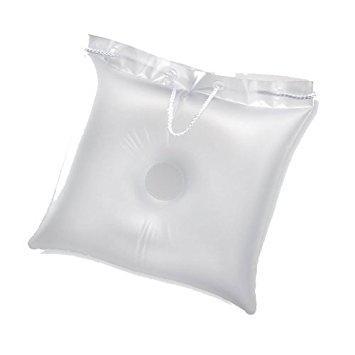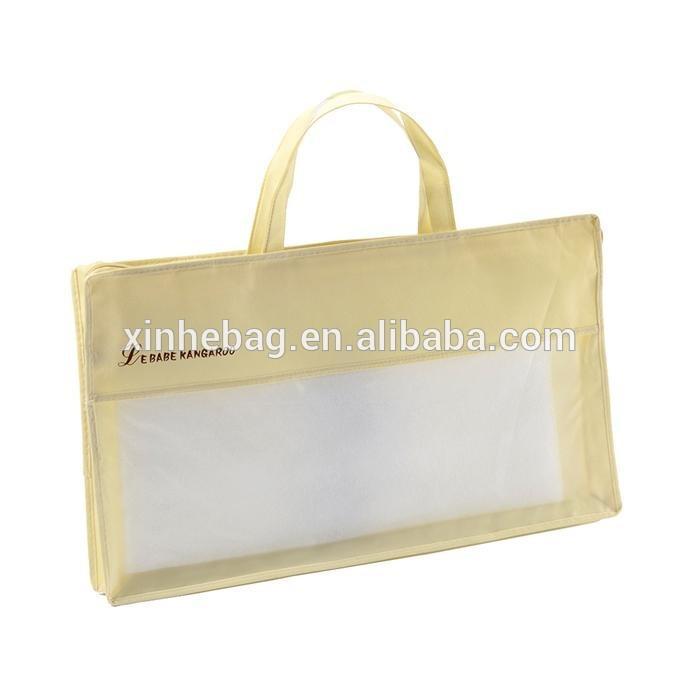The first image is the image on the left, the second image is the image on the right. Examine the images to the left and right. Is the description "The left image contains a handled pillow shape with black text printed on its front, and the right image features a pillow with no handle." accurate? Answer yes or no. No. The first image is the image on the left, the second image is the image on the right. Examine the images to the left and right. Is the description "The left and right image contains the same number of white pillows" accurate? Answer yes or no. No. 